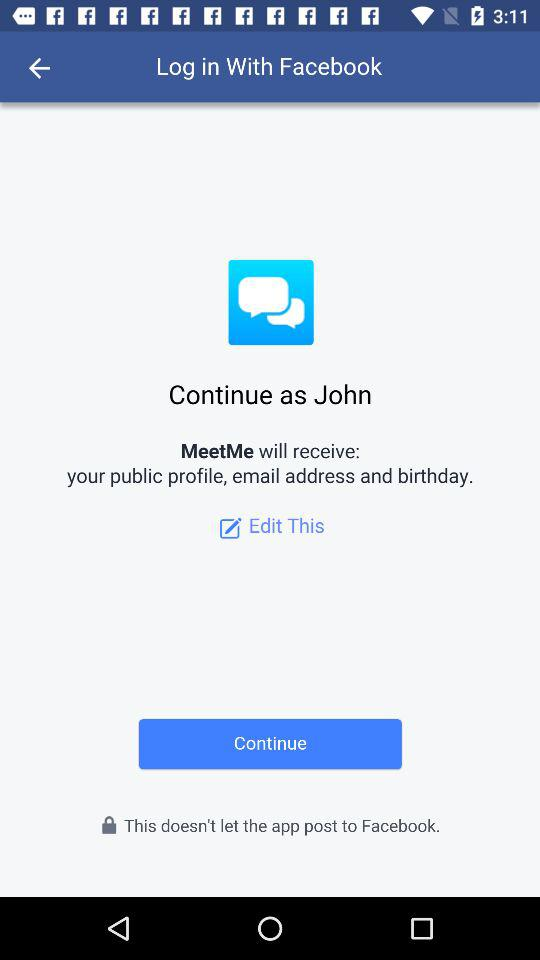What is the login name? The login name is John. 